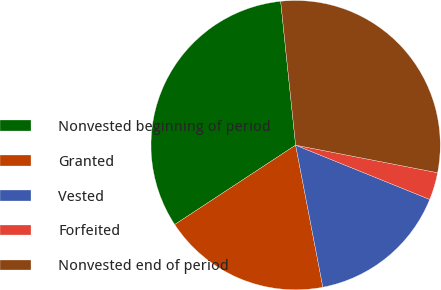<chart> <loc_0><loc_0><loc_500><loc_500><pie_chart><fcel>Nonvested beginning of period<fcel>Granted<fcel>Vested<fcel>Forfeited<fcel>Nonvested end of period<nl><fcel>32.6%<fcel>18.77%<fcel>15.86%<fcel>3.07%<fcel>29.7%<nl></chart> 